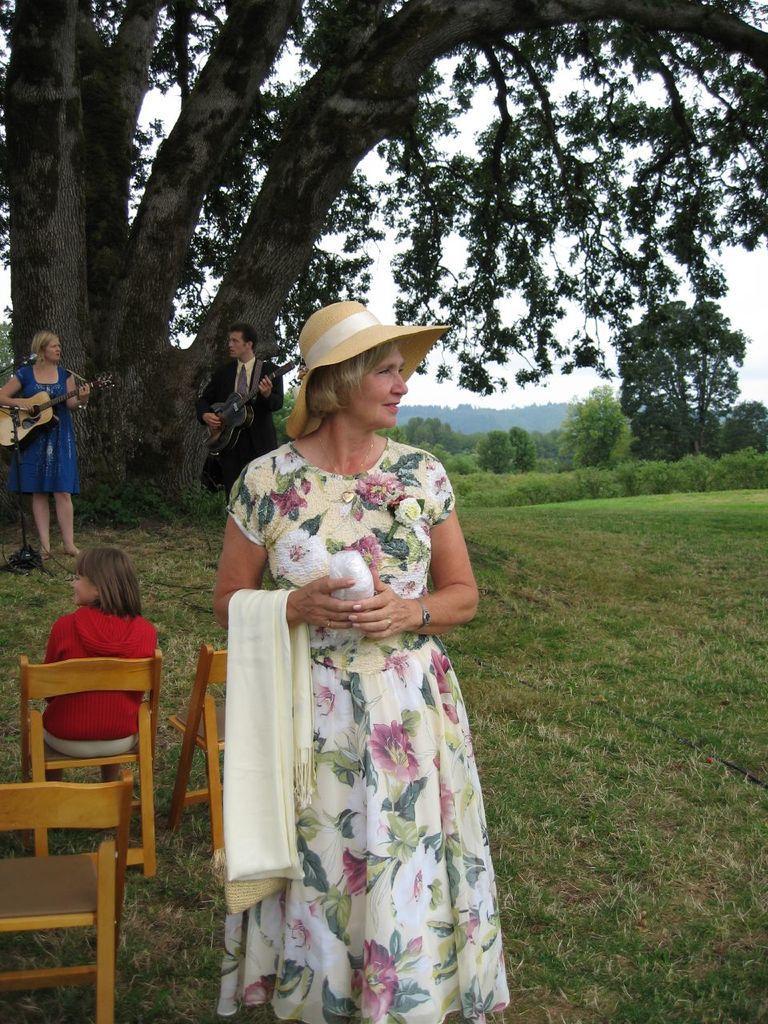How would you summarize this image in a sentence or two? There is a woman standing on the land, holding cloth in her hand. She's wearing a hat on her head. In the background, there are two people playing guitars in their hands. One girl is sitting in the chair. There is a tree and sky here. 